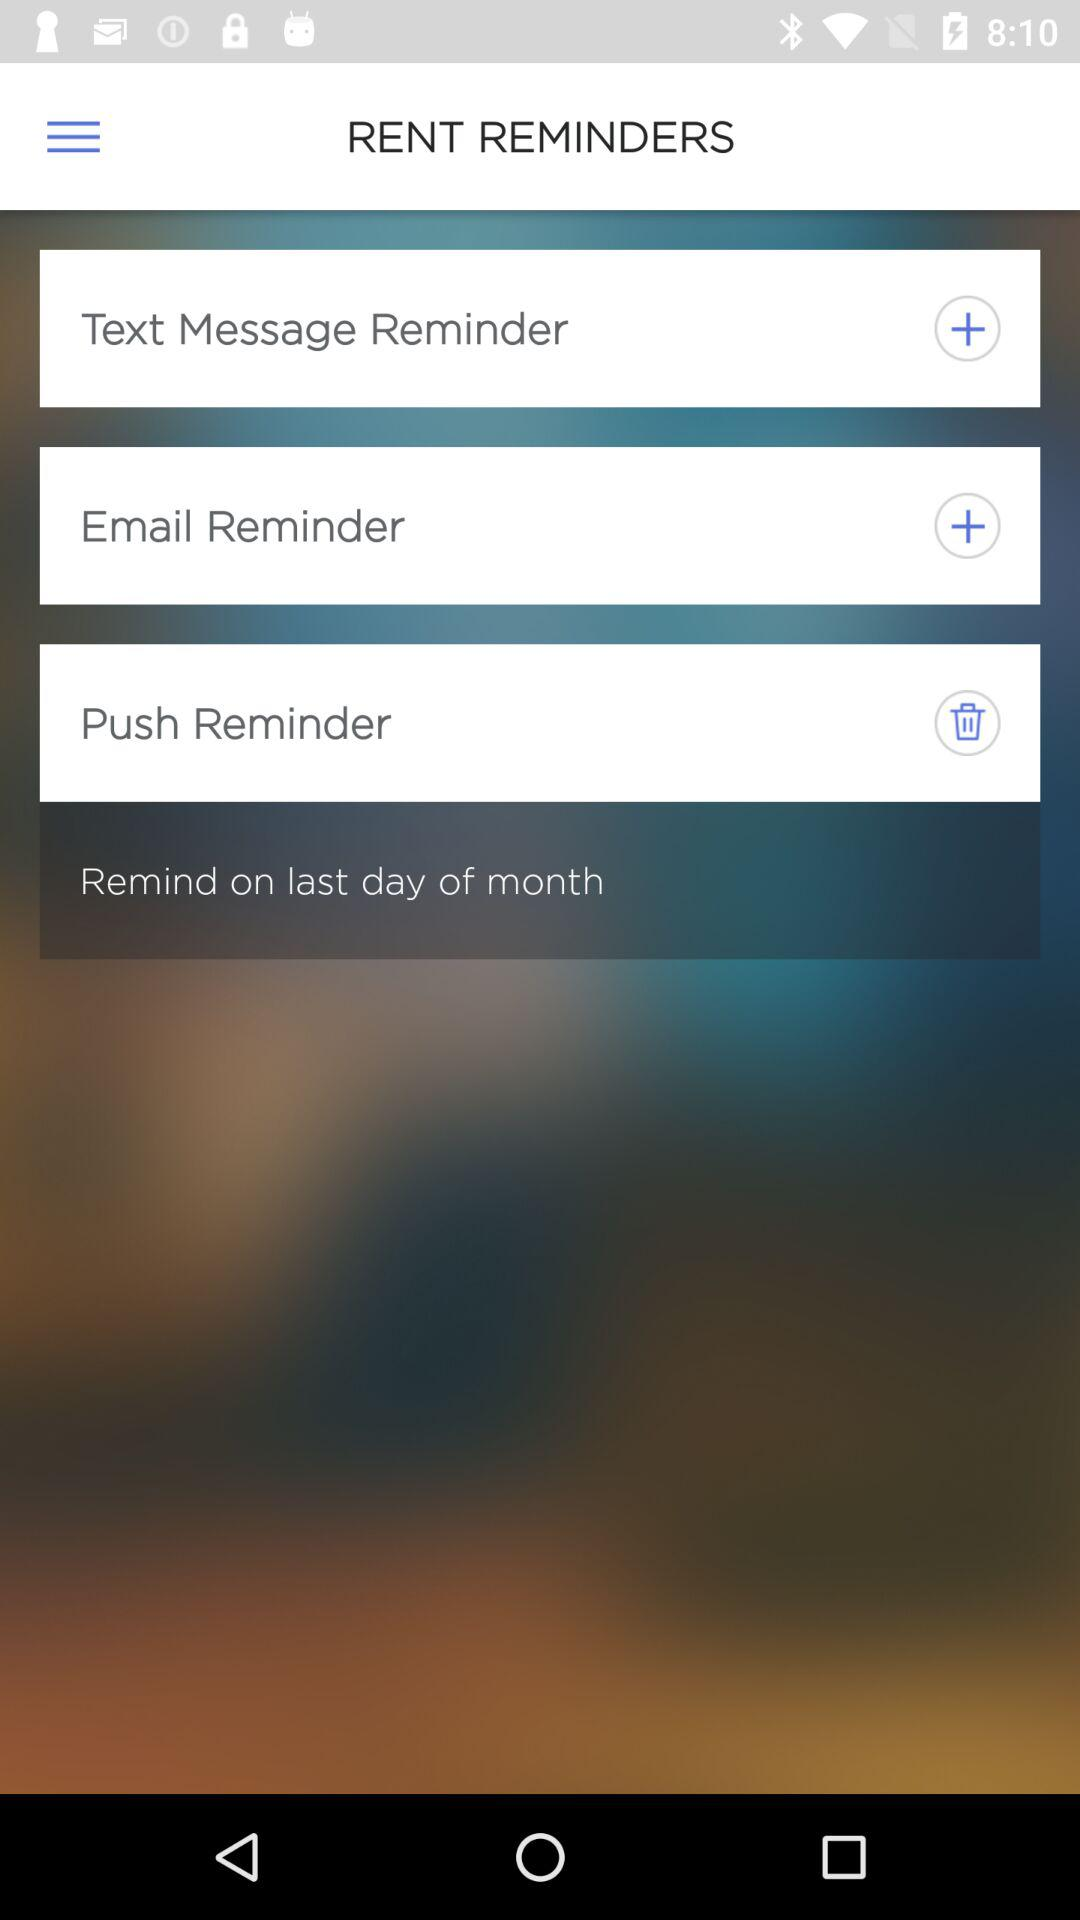How often are the text reminders?
When the provided information is insufficient, respond with <no answer>. <no answer> 